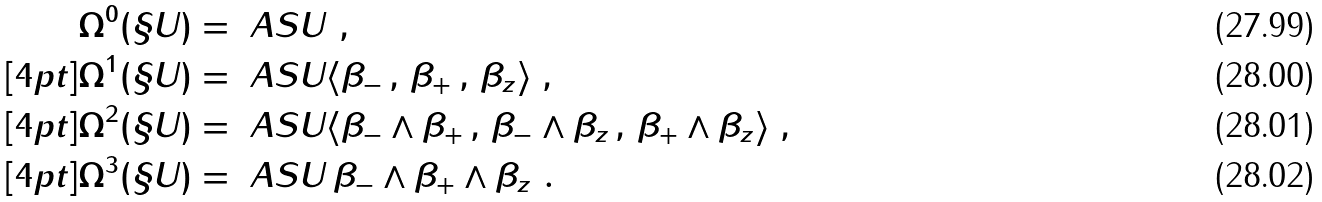<formula> <loc_0><loc_0><loc_500><loc_500>\Omega ^ { 0 } ( \S U ) & = \ A S U \ , \\ [ 4 p t ] \Omega ^ { 1 } ( \S U ) & = \ A S U \langle \beta _ { - } \, , \, \beta _ { + } \, , \, \beta _ { z } \rangle \ , \\ [ 4 p t ] \Omega ^ { 2 } ( \S U ) & = \ A S U \langle \beta _ { - } \wedge \beta _ { + } \, , \, \beta _ { - } \wedge \beta _ { z } \, , \, \beta _ { + } \wedge \beta _ { z } \rangle \ , \\ [ 4 p t ] \Omega ^ { 3 } ( \S U ) & = \ A S U \, \beta _ { - } \wedge \beta _ { + } \wedge \beta _ { z } \ .</formula> 